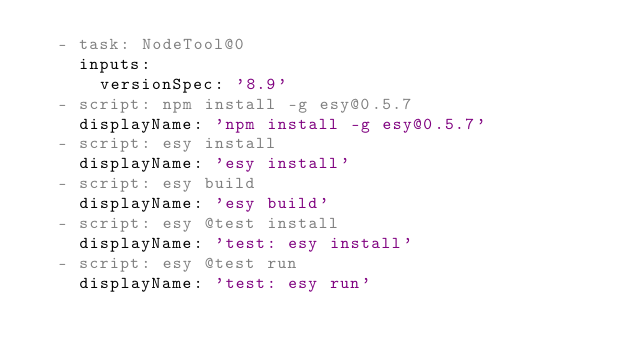<code> <loc_0><loc_0><loc_500><loc_500><_YAML_>  - task: NodeTool@0
    inputs:
      versionSpec: '8.9'
  - script: npm install -g esy@0.5.7
    displayName: 'npm install -g esy@0.5.7'
  - script: esy install
    displayName: 'esy install'
  - script: esy build
    displayName: 'esy build'
  - script: esy @test install
    displayName: 'test: esy install'
  - script: esy @test run
    displayName: 'test: esy run'
</code> 